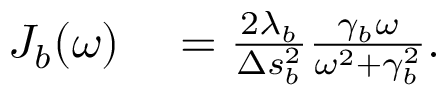<formula> <loc_0><loc_0><loc_500><loc_500>\begin{array} { r l } { J _ { b } ( \omega ) } & = \frac { 2 \lambda _ { b } } { \Delta s _ { b } ^ { 2 } } \frac { \gamma _ { b } \omega } { \omega ^ { 2 } + \gamma _ { b } ^ { 2 } } . } \end{array}</formula> 